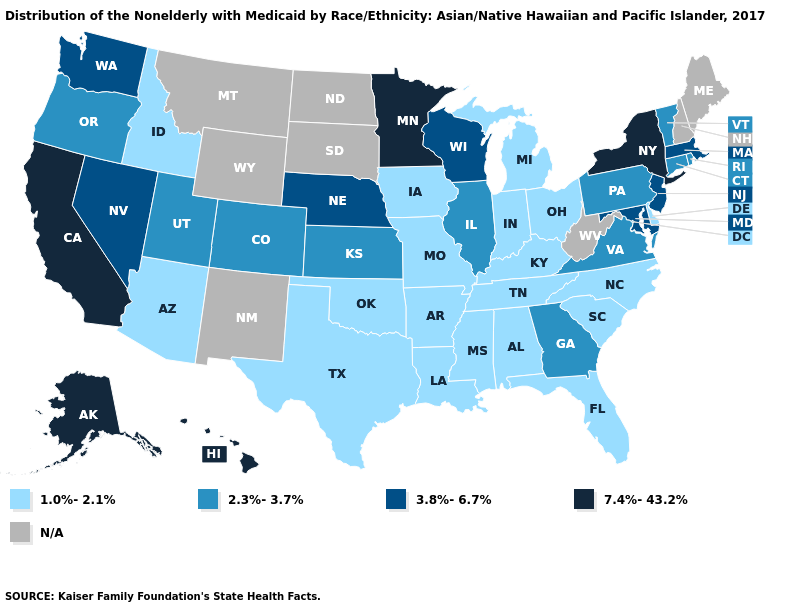Does Vermont have the highest value in the USA?
Give a very brief answer. No. Does Kansas have the lowest value in the MidWest?
Answer briefly. No. Does North Carolina have the highest value in the USA?
Keep it brief. No. What is the lowest value in the Northeast?
Short answer required. 2.3%-3.7%. What is the value of Missouri?
Quick response, please. 1.0%-2.1%. Name the states that have a value in the range 3.8%-6.7%?
Write a very short answer. Maryland, Massachusetts, Nebraska, Nevada, New Jersey, Washington, Wisconsin. Name the states that have a value in the range 7.4%-43.2%?
Keep it brief. Alaska, California, Hawaii, Minnesota, New York. Which states hav the highest value in the Northeast?
Write a very short answer. New York. Which states have the lowest value in the USA?
Write a very short answer. Alabama, Arizona, Arkansas, Delaware, Florida, Idaho, Indiana, Iowa, Kentucky, Louisiana, Michigan, Mississippi, Missouri, North Carolina, Ohio, Oklahoma, South Carolina, Tennessee, Texas. What is the highest value in states that border South Carolina?
Give a very brief answer. 2.3%-3.7%. Does Connecticut have the lowest value in the USA?
Concise answer only. No. What is the highest value in the Northeast ?
Give a very brief answer. 7.4%-43.2%. 